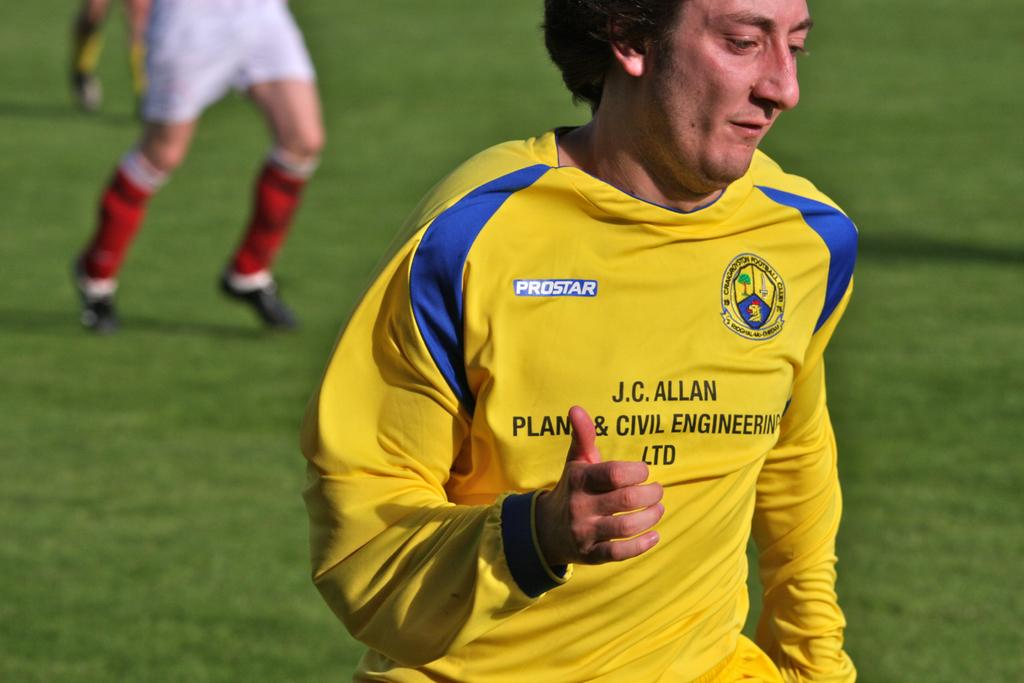<image>
Render a clear and concise summary of the photo. A man in a Prostar shirt gives the thumbs up. 